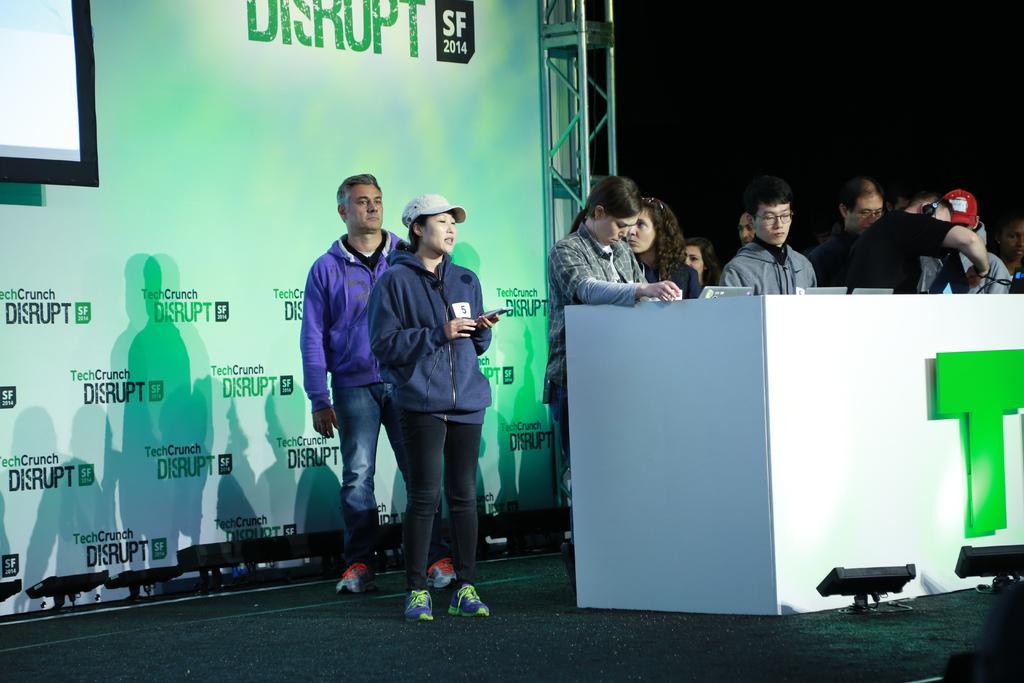Could you give a brief overview of what you see in this image? There are few persons standing and there is a table in front of them which has few laptops placed on it and there is a banner behind them which has something written on it. 